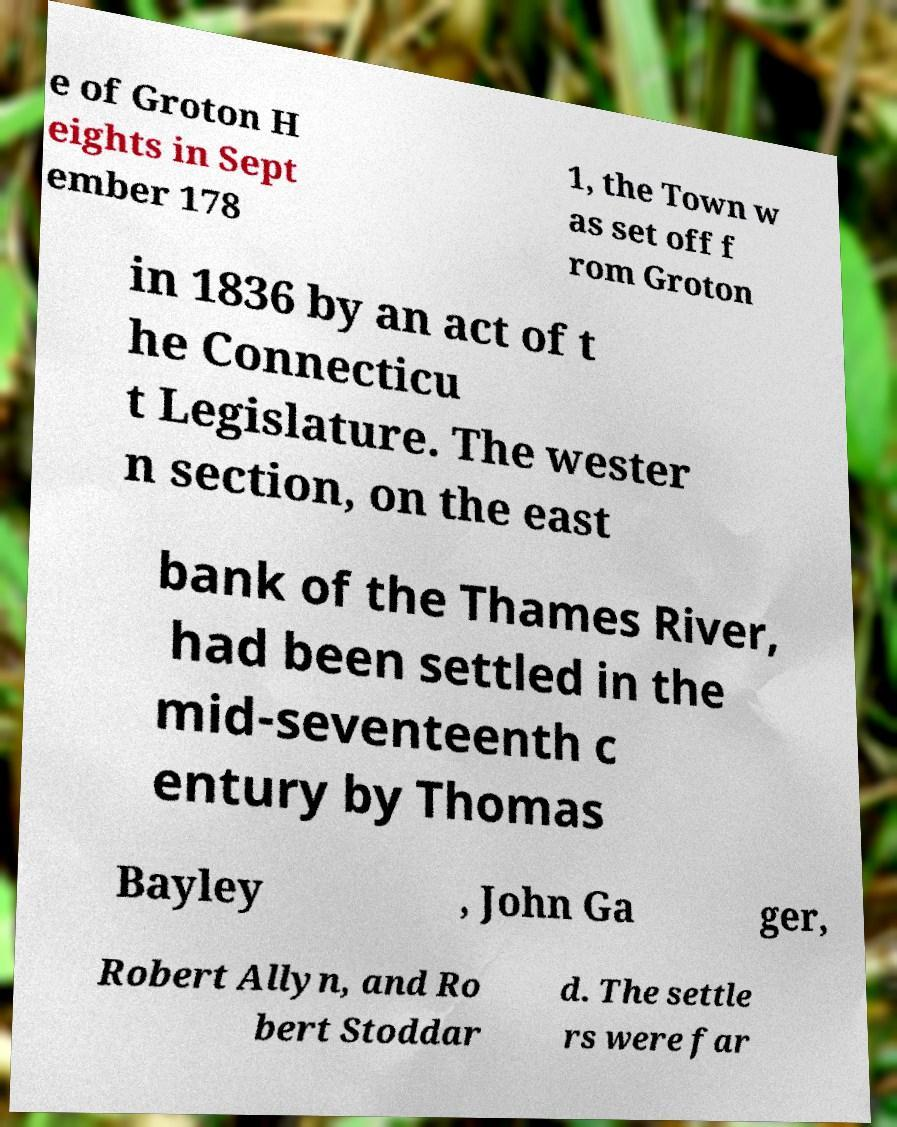Please read and relay the text visible in this image. What does it say? e of Groton H eights in Sept ember 178 1, the Town w as set off f rom Groton in 1836 by an act of t he Connecticu t Legislature. The wester n section, on the east bank of the Thames River, had been settled in the mid-seventeenth c entury by Thomas Bayley , John Ga ger, Robert Allyn, and Ro bert Stoddar d. The settle rs were far 